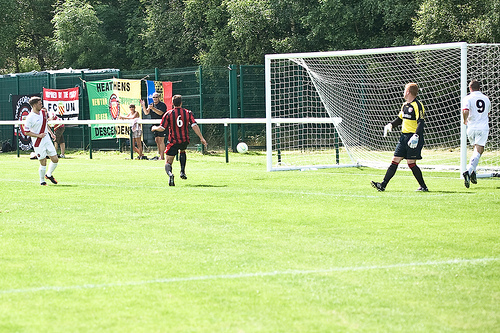<image>
Can you confirm if the playground is under the man? No. The playground is not positioned under the man. The vertical relationship between these objects is different. 